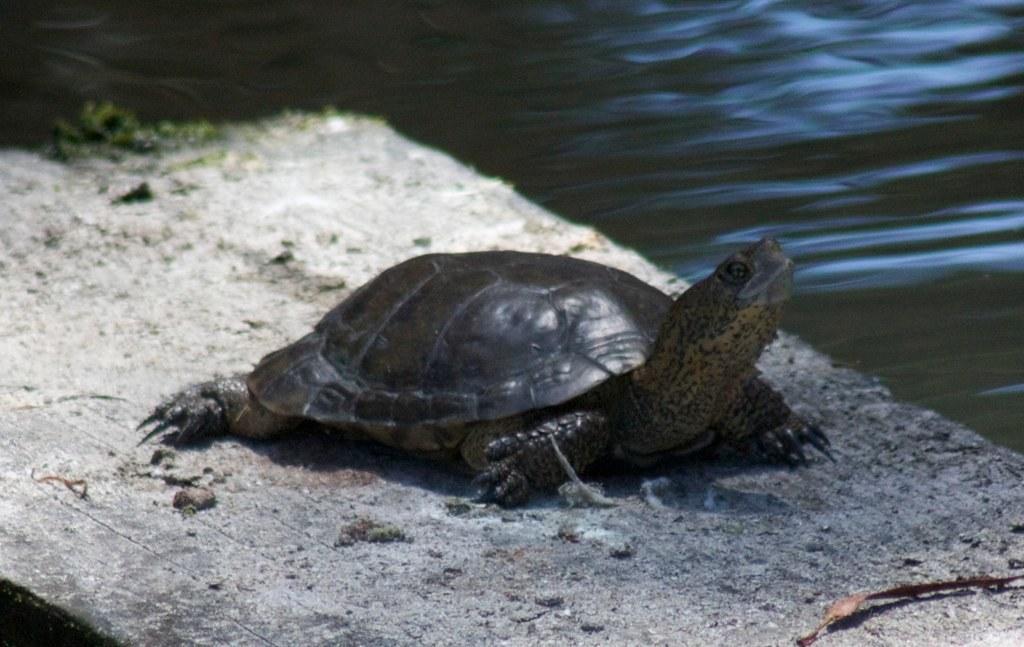How would you summarize this image in a sentence or two? In the image there is a tortoise on the wooden surface. Beside that wooden surface on the right side of the image there is water. 